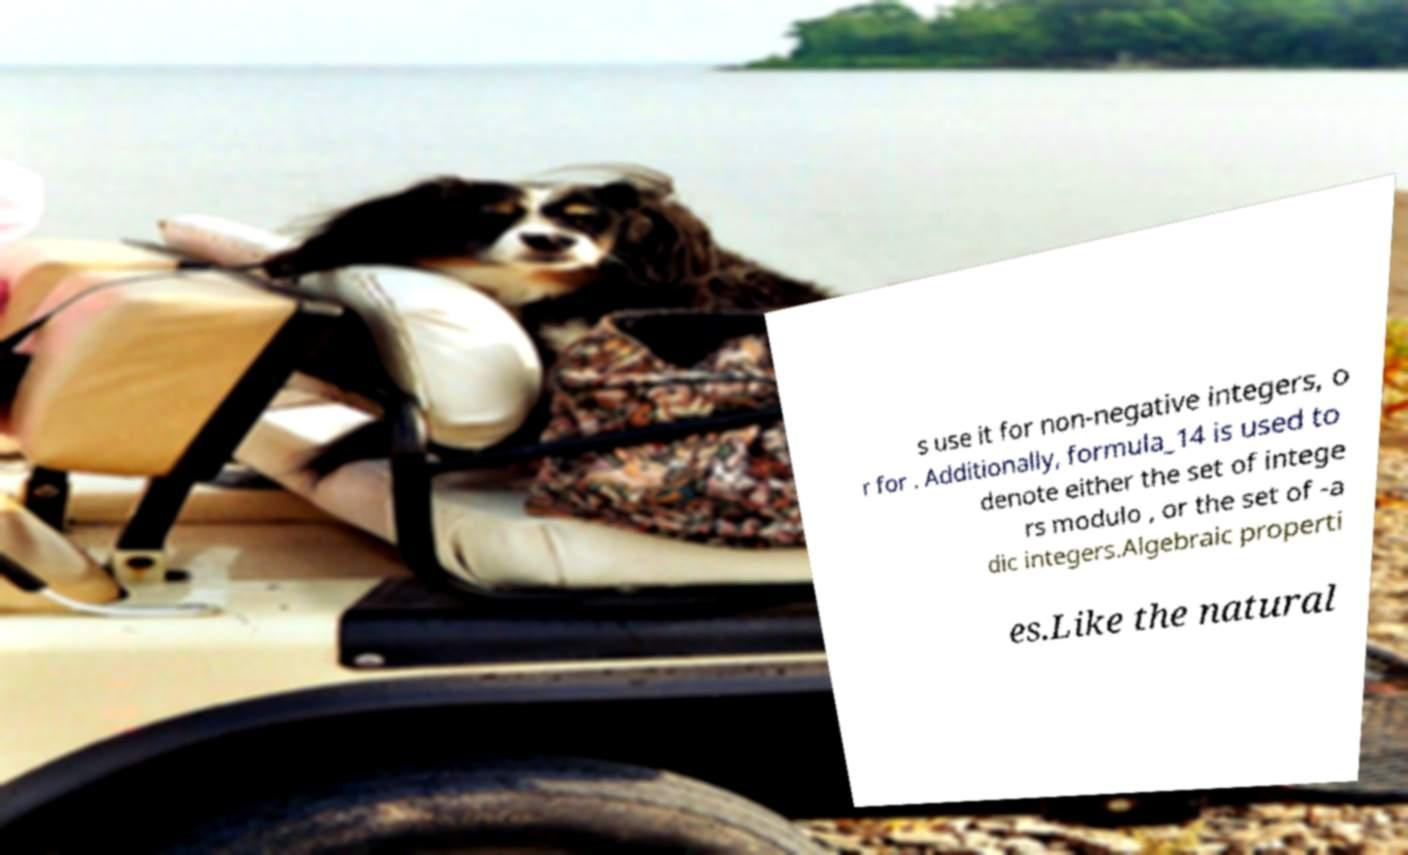What messages or text are displayed in this image? I need them in a readable, typed format. s use it for non-negative integers, o r for . Additionally, formula_14 is used to denote either the set of intege rs modulo , or the set of -a dic integers.Algebraic properti es.Like the natural 